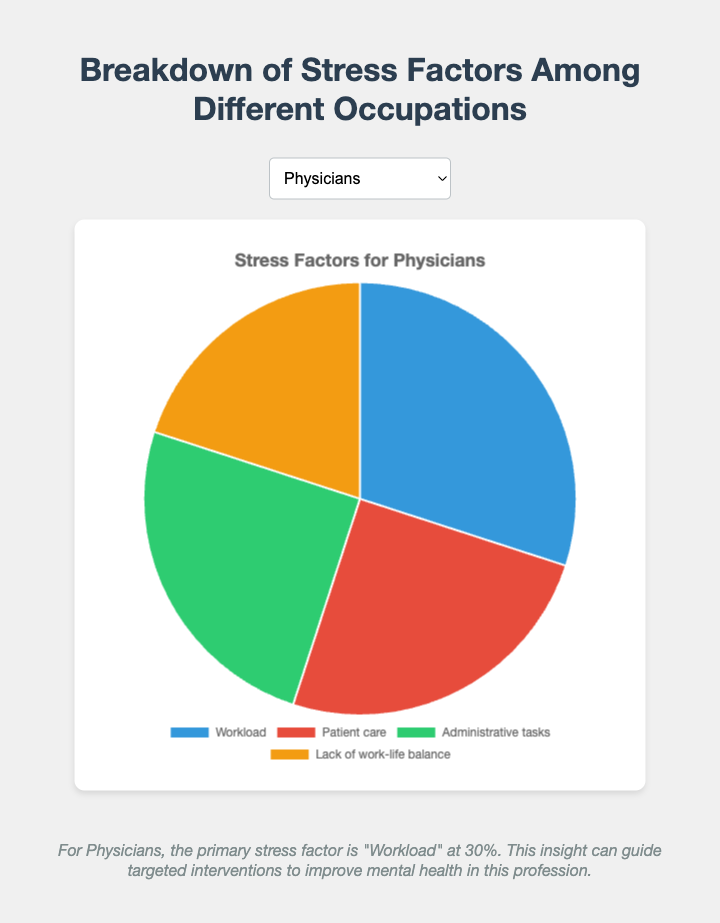What's the predominant stress factor for Physicians? The pie chart should demonstrate that for Physicians, the largest portion of the pie is attributed to "Workload". This section occupies 30% of the stress factors for Physicians.
Answer: Workload Which occupation has the highest percentage dedicated to a single stress factor? By examining the pie charts, it's clear that Software Engineers have "Tight deadlines" occupying 40%, which is the largest single factor across all occupations.
Answer: Software Engineers How do the stress factors due to administrative tasks compare between Physicians and Teachers? For Physicians, administrative tasks account for 25% of their stress factors, while for Teachers it accounts for 20%. Therefore, Physicians experience a higher stress due to administrative tasks by 5%.
Answer: Physicians have a 5% higher stress due to administrative tasks What is the combined stress percentage from workload and patient care for Physicians? Adding the percentages for workload (30%) and patient care (25%) for Physicians results in 55%.
Answer: - 55% Which stress factor is described with a green-colored segment for Software Engineers? Observing the chart, we find that "Constant learning" is represented with the green-colored segment for Software Engineers, accounting for 15%.
Answer: Constant learning Do Retail Workers experience more stress from customer interactions or job insecurity? In the pie chart for Retail Workers, customer interactions account for 35% while job insecurity accounts for 20%. Clearly, customer interactions are a greater source of stress.
Answer: Customer interactions If we sum the stress factors 'Classroom management' and 'Parental expectations' for Teachers, what is the result? The stress factors for classroom management (30%) and parental expectations (15%) total 45%.
Answer: 45% Compare the stress due to lack of work-life balance between Physicians and Software Engineers. Who is more affected? The pie chart reveals that Software Engineers have 30% stress due to work-life balance, while Physicians have 20%. Hence, Software Engineers are more affected.
Answer: Software Engineers What percentage of stress factors for Teachers is not related to workload? The stress factors for Teachers excluding workload (35%) are classroom management (30%), administrative tasks (20%), and parental expectations (15%), which add up to 65%.
Answer: 65% In the case of Retail Workers, which stress factor occupies the least percentage and what is the percentage? The pie chart shows that for Retail Workers, "Job insecurity" occupies the least percentage at 20%.
Answer: Job insecurity, 20% 